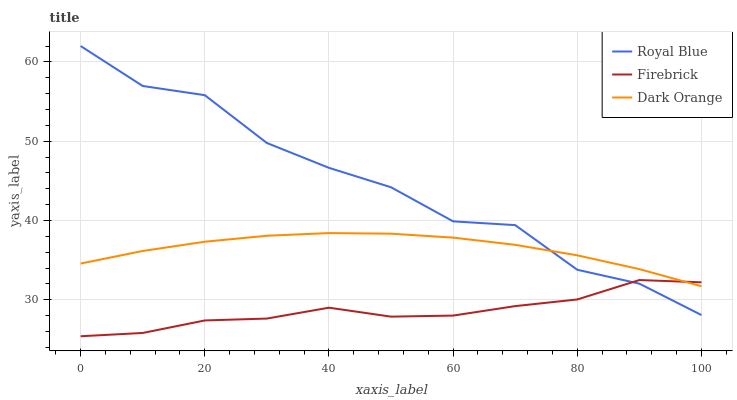Does Firebrick have the minimum area under the curve?
Answer yes or no. Yes. Does Royal Blue have the maximum area under the curve?
Answer yes or no. Yes. Does Dark Orange have the minimum area under the curve?
Answer yes or no. No. Does Dark Orange have the maximum area under the curve?
Answer yes or no. No. Is Dark Orange the smoothest?
Answer yes or no. Yes. Is Royal Blue the roughest?
Answer yes or no. Yes. Is Firebrick the smoothest?
Answer yes or no. No. Is Firebrick the roughest?
Answer yes or no. No. Does Firebrick have the lowest value?
Answer yes or no. Yes. Does Dark Orange have the lowest value?
Answer yes or no. No. Does Royal Blue have the highest value?
Answer yes or no. Yes. Does Dark Orange have the highest value?
Answer yes or no. No. Does Royal Blue intersect Dark Orange?
Answer yes or no. Yes. Is Royal Blue less than Dark Orange?
Answer yes or no. No. Is Royal Blue greater than Dark Orange?
Answer yes or no. No. 